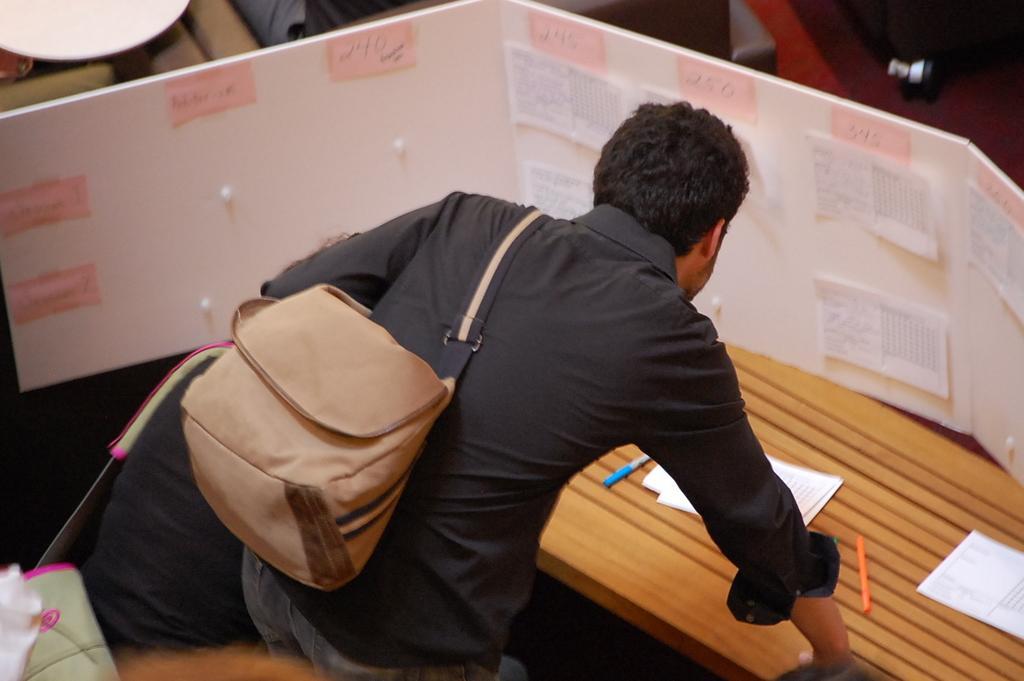Can you describe this image briefly? In this image there is a person standing wearing bag in front of table where we can see there are some pens and paper. 